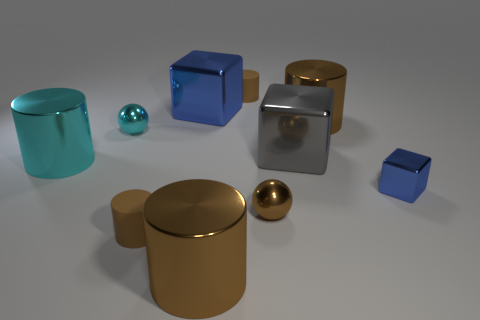Does the cylinder right of the large gray cube have the same color as the sphere that is to the right of the small cyan shiny thing?
Offer a very short reply. Yes. Are there any tiny cyan balls made of the same material as the gray block?
Keep it short and to the point. Yes. How many red objects are either tiny matte cylinders or cylinders?
Offer a terse response. 0. Are there more big blue blocks that are behind the big gray shiny cube than red shiny balls?
Your response must be concise. Yes. Is the size of the gray shiny object the same as the cyan cylinder?
Your answer should be compact. Yes. There is a small block that is made of the same material as the large cyan object; what is its color?
Make the answer very short. Blue. The big metallic object that is the same color as the tiny cube is what shape?
Your response must be concise. Cube. Are there an equal number of large brown cylinders that are left of the brown sphere and blocks to the left of the small shiny block?
Provide a succinct answer. No. The tiny rubber object left of the large brown cylinder that is in front of the large gray shiny thing is what shape?
Your answer should be very brief. Cylinder. What is the color of the block that is the same size as the cyan ball?
Offer a terse response. Blue. 